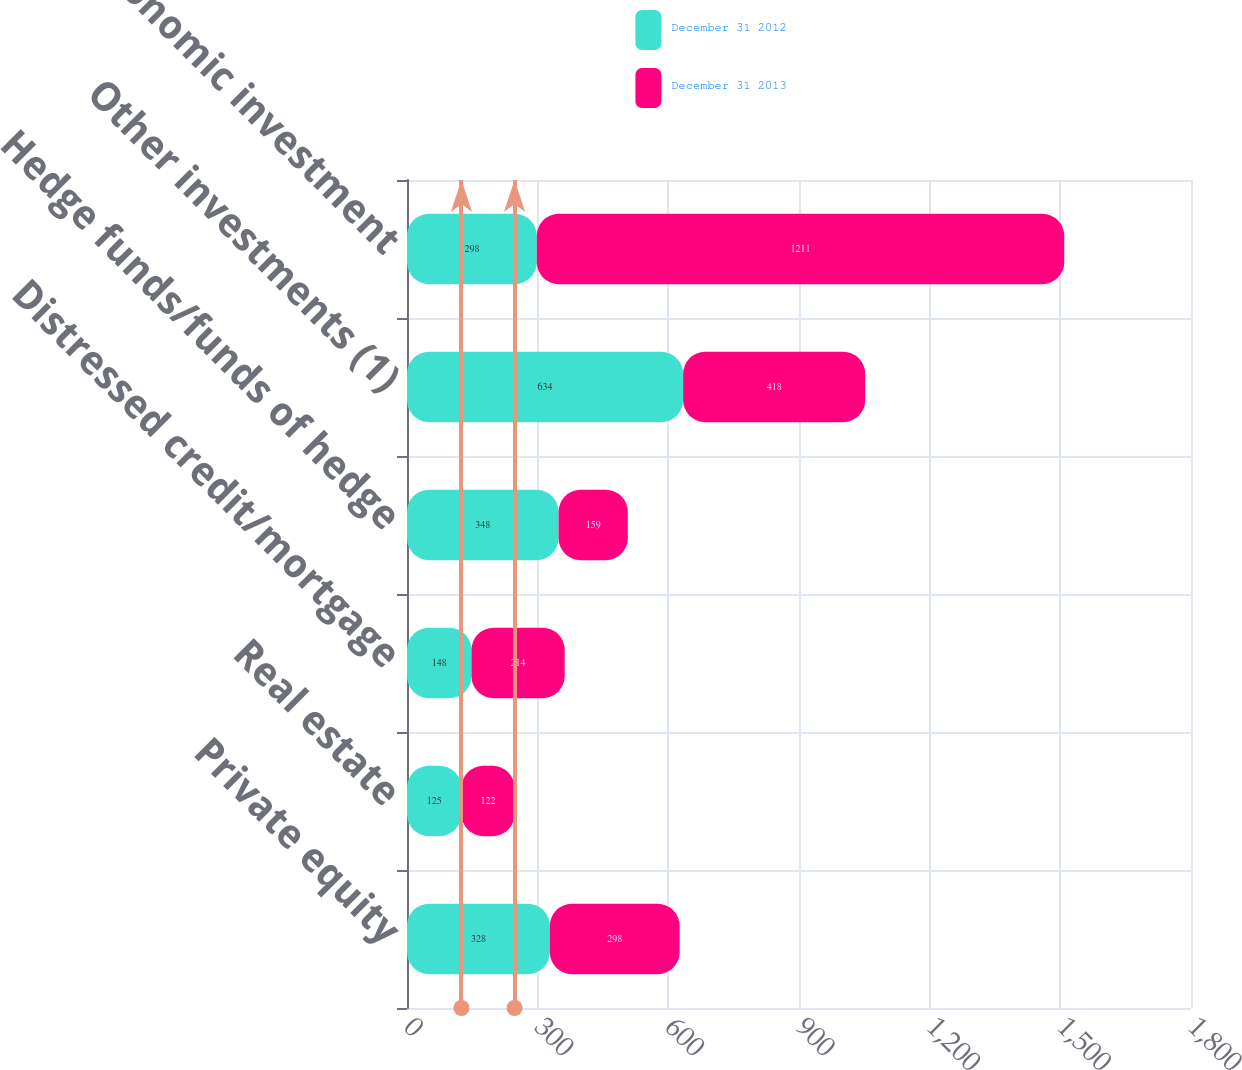Convert chart to OTSL. <chart><loc_0><loc_0><loc_500><loc_500><stacked_bar_chart><ecel><fcel>Private equity<fcel>Real estate<fcel>Distressed credit/mortgage<fcel>Hedge funds/funds of hedge<fcel>Other investments (1)<fcel>Total economic investment<nl><fcel>December 31 2012<fcel>328<fcel>125<fcel>148<fcel>348<fcel>634<fcel>298<nl><fcel>December 31 2013<fcel>298<fcel>122<fcel>214<fcel>159<fcel>418<fcel>1211<nl></chart> 